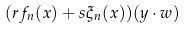Convert formula to latex. <formula><loc_0><loc_0><loc_500><loc_500>( r f _ { n } ( x ) + s \xi _ { n } ( x ) ) ( y \cdot w )</formula> 